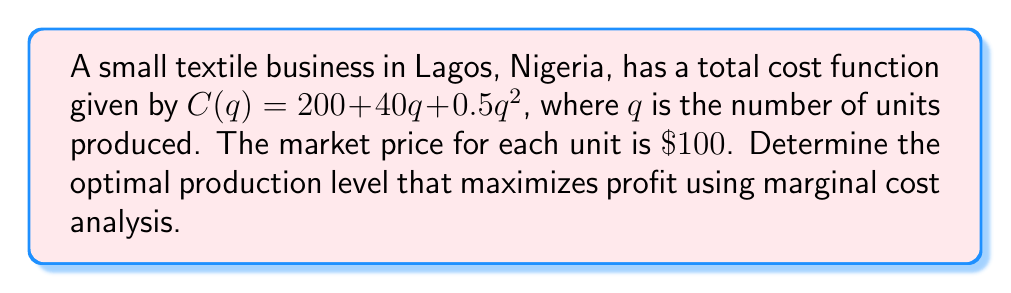Can you solve this math problem? To find the optimal production level, we need to follow these steps:

1) First, let's define the profit function:
   Profit = Revenue - Cost
   $P(q) = 100q - (200 + 40q + 0.5q^2)$
   $P(q) = 100q - 200 - 40q - 0.5q^2$
   $P(q) = 60q - 200 - 0.5q^2$

2) The optimal production level occurs where Marginal Revenue (MR) equals Marginal Cost (MC).

3) Marginal Revenue is constant and equal to the price:
   $MR = 100$

4) To find Marginal Cost, we need to differentiate the cost function:
   $C(q) = 200 + 40q + 0.5q^2$
   $MC = \frac{dC}{dq} = 40 + q$

5) Set MR = MC:
   $100 = 40 + q$

6) Solve for q:
   $q = 60$

7) To confirm this is a maximum (not minimum) profit, we can check the second derivative of the profit function:
   $\frac{d^2P}{dq^2} = -1 < 0$, which confirms a maximum.

Therefore, the optimal production level is 60 units.
Answer: 60 units 